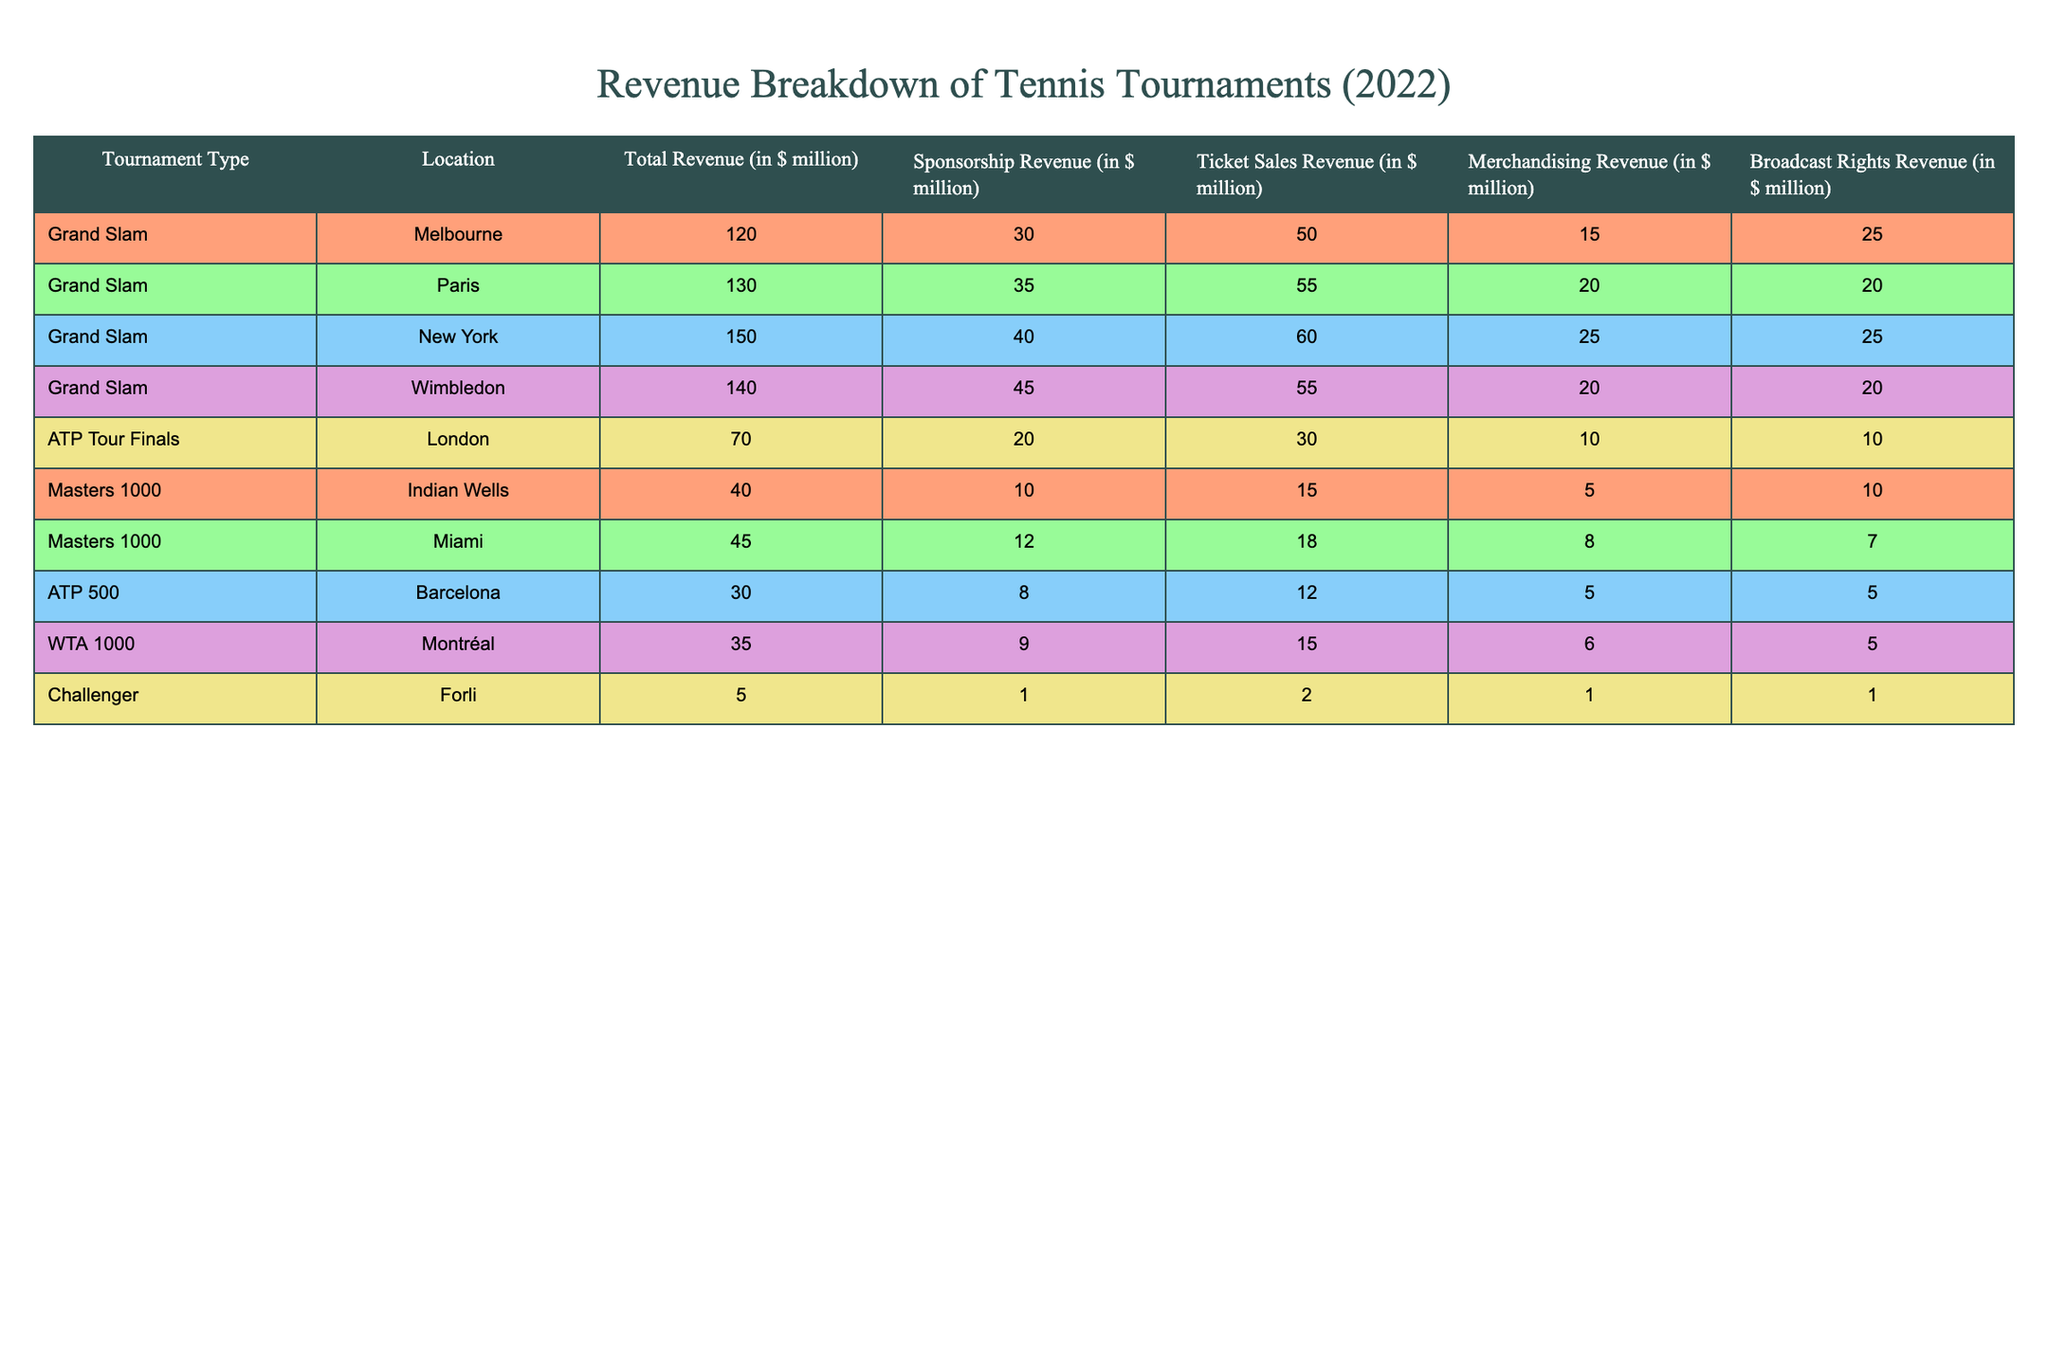What is the total revenue generated from the Grand Slam tournaments in 2022? The total revenue of Grand Slam tournaments can be calculated by adding the revenues from each of the four locations: Melbourne (120 million), Paris (130 million), New York (150 million), and Wimbledon (140 million). So, 120 + 130 + 150 + 140 = 540 million dollars.
Answer: 540 million Which tournament generated the highest sponsorship revenue in 2022? From the table, we identify the sponsorship revenues: Melbourne (30 million), Paris (35 million), New York (40 million), Wimbledon (45 million), London (20 million), Indian Wells (10 million), Miami (12 million), Barcelona (8 million), Montréal (9 million), and Forli (1 million). The highest is Wimbledon with 45 million dollars.
Answer: Wimbledon What percentage of the total revenue from the ATP Tour Finals came from ticket sales? The total revenue for the ATP Tour Finals is 70 million dollars, and ticket sales revenue is 30 million dollars. The percentage can be calculated as (30/70) * 100 = 42.86 percent.
Answer: 42.86 percent Is the broadcast rights revenue for Masters 1000 tournaments combined greater than that for Grand Slam tournaments? The broadcast rights revenue for Masters 1000 tournaments (Indian Wells 10 million + Miami 7 million = 17 million) is compared with Grand Slam tournaments (Melbourne 25 million + Paris 20 million + New York 25 million + Wimbledon 20 million = 90 million). Since 17 million is less than 90 million, the statement is false.
Answer: No What is the average ticket sales revenue across all the tournaments presented in the table? To find the average ticket sales revenue, first sum the ticket sales: 50 (Melbourne) + 55 (Paris) + 60 (New York) + 55 (Wimbledon) + 30 (London) + 15 (Indian Wells) + 18 (Miami) + 12 (Barcelona) + 15 (Montréal) + 2 (Forli) = 318 million. There are 10 tournaments, so the average is 318/10 = 31.8 million dollars.
Answer: 31.8 million Which location had the lowest total revenue among all tournaments? By examining the total revenue figures: Melbourne (120 million), Paris (130 million), New York (150 million), Wimbledon (140 million), London (70 million), Indian Wells (40 million), Miami (45 million), Barcelona (30 million), Montréal (35 million), and Forli (5 million), Forli had the lowest at 5 million dollars.
Answer: Forli 